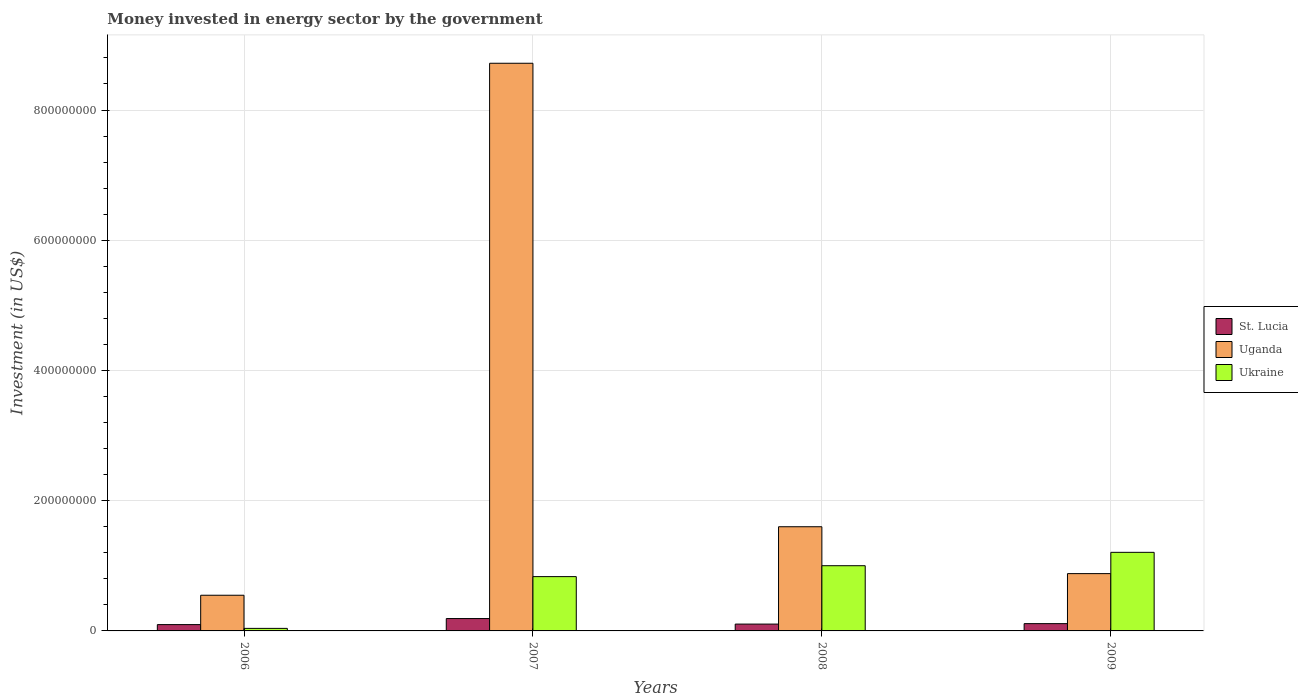How many groups of bars are there?
Your answer should be compact. 4. In how many cases, is the number of bars for a given year not equal to the number of legend labels?
Make the answer very short. 0. What is the money spent in energy sector in Ukraine in 2007?
Offer a terse response. 8.34e+07. Across all years, what is the maximum money spent in energy sector in Ukraine?
Ensure brevity in your answer.  1.21e+08. Across all years, what is the minimum money spent in energy sector in Uganda?
Provide a succinct answer. 5.48e+07. In which year was the money spent in energy sector in St. Lucia maximum?
Ensure brevity in your answer.  2007. What is the total money spent in energy sector in St. Lucia in the graph?
Offer a terse response. 5.04e+07. What is the difference between the money spent in energy sector in Uganda in 2006 and that in 2007?
Make the answer very short. -8.17e+08. What is the difference between the money spent in energy sector in St. Lucia in 2008 and the money spent in energy sector in Ukraine in 2006?
Your answer should be very brief. 6.60e+06. What is the average money spent in energy sector in Uganda per year?
Your answer should be compact. 2.94e+08. In the year 2008, what is the difference between the money spent in energy sector in Uganda and money spent in energy sector in St. Lucia?
Keep it short and to the point. 1.50e+08. In how many years, is the money spent in energy sector in St. Lucia greater than 800000000 US$?
Offer a very short reply. 0. What is the ratio of the money spent in energy sector in St. Lucia in 2006 to that in 2009?
Your response must be concise. 0.87. Is the difference between the money spent in energy sector in Uganda in 2008 and 2009 greater than the difference between the money spent in energy sector in St. Lucia in 2008 and 2009?
Keep it short and to the point. Yes. What is the difference between the highest and the second highest money spent in energy sector in Ukraine?
Offer a terse response. 2.06e+07. What is the difference between the highest and the lowest money spent in energy sector in Uganda?
Provide a succinct answer. 8.17e+08. In how many years, is the money spent in energy sector in Ukraine greater than the average money spent in energy sector in Ukraine taken over all years?
Ensure brevity in your answer.  3. Is the sum of the money spent in energy sector in St. Lucia in 2007 and 2009 greater than the maximum money spent in energy sector in Uganda across all years?
Your response must be concise. No. What does the 1st bar from the left in 2006 represents?
Offer a very short reply. St. Lucia. What does the 3rd bar from the right in 2006 represents?
Give a very brief answer. St. Lucia. Is it the case that in every year, the sum of the money spent in energy sector in St. Lucia and money spent in energy sector in Uganda is greater than the money spent in energy sector in Ukraine?
Provide a succinct answer. No. How many years are there in the graph?
Provide a succinct answer. 4. How many legend labels are there?
Keep it short and to the point. 3. How are the legend labels stacked?
Give a very brief answer. Vertical. What is the title of the graph?
Give a very brief answer. Money invested in energy sector by the government. Does "Tuvalu" appear as one of the legend labels in the graph?
Provide a succinct answer. No. What is the label or title of the X-axis?
Make the answer very short. Years. What is the label or title of the Y-axis?
Your answer should be compact. Investment (in US$). What is the Investment (in US$) of St. Lucia in 2006?
Make the answer very short. 9.70e+06. What is the Investment (in US$) in Uganda in 2006?
Provide a short and direct response. 5.48e+07. What is the Investment (in US$) in Ukraine in 2006?
Your answer should be very brief. 3.90e+06. What is the Investment (in US$) of St. Lucia in 2007?
Ensure brevity in your answer.  1.90e+07. What is the Investment (in US$) of Uganda in 2007?
Provide a short and direct response. 8.72e+08. What is the Investment (in US$) in Ukraine in 2007?
Your answer should be very brief. 8.34e+07. What is the Investment (in US$) of St. Lucia in 2008?
Ensure brevity in your answer.  1.05e+07. What is the Investment (in US$) of Uganda in 2008?
Your answer should be compact. 1.60e+08. What is the Investment (in US$) in Ukraine in 2008?
Your response must be concise. 1.00e+08. What is the Investment (in US$) in St. Lucia in 2009?
Your answer should be very brief. 1.12e+07. What is the Investment (in US$) of Uganda in 2009?
Give a very brief answer. 8.80e+07. What is the Investment (in US$) of Ukraine in 2009?
Offer a terse response. 1.21e+08. Across all years, what is the maximum Investment (in US$) in St. Lucia?
Provide a short and direct response. 1.90e+07. Across all years, what is the maximum Investment (in US$) of Uganda?
Offer a very short reply. 8.72e+08. Across all years, what is the maximum Investment (in US$) in Ukraine?
Offer a terse response. 1.21e+08. Across all years, what is the minimum Investment (in US$) in St. Lucia?
Make the answer very short. 9.70e+06. Across all years, what is the minimum Investment (in US$) of Uganda?
Make the answer very short. 5.48e+07. Across all years, what is the minimum Investment (in US$) in Ukraine?
Your answer should be very brief. 3.90e+06. What is the total Investment (in US$) of St. Lucia in the graph?
Provide a succinct answer. 5.04e+07. What is the total Investment (in US$) of Uganda in the graph?
Give a very brief answer. 1.17e+09. What is the total Investment (in US$) of Ukraine in the graph?
Ensure brevity in your answer.  3.08e+08. What is the difference between the Investment (in US$) of St. Lucia in 2006 and that in 2007?
Your response must be concise. -9.30e+06. What is the difference between the Investment (in US$) of Uganda in 2006 and that in 2007?
Offer a very short reply. -8.17e+08. What is the difference between the Investment (in US$) in Ukraine in 2006 and that in 2007?
Your answer should be compact. -7.95e+07. What is the difference between the Investment (in US$) of St. Lucia in 2006 and that in 2008?
Keep it short and to the point. -8.00e+05. What is the difference between the Investment (in US$) in Uganda in 2006 and that in 2008?
Provide a short and direct response. -1.05e+08. What is the difference between the Investment (in US$) of Ukraine in 2006 and that in 2008?
Your answer should be compact. -9.62e+07. What is the difference between the Investment (in US$) in St. Lucia in 2006 and that in 2009?
Keep it short and to the point. -1.50e+06. What is the difference between the Investment (in US$) in Uganda in 2006 and that in 2009?
Offer a very short reply. -3.32e+07. What is the difference between the Investment (in US$) of Ukraine in 2006 and that in 2009?
Give a very brief answer. -1.17e+08. What is the difference between the Investment (in US$) of St. Lucia in 2007 and that in 2008?
Offer a terse response. 8.50e+06. What is the difference between the Investment (in US$) in Uganda in 2007 and that in 2008?
Your answer should be very brief. 7.12e+08. What is the difference between the Investment (in US$) of Ukraine in 2007 and that in 2008?
Offer a very short reply. -1.67e+07. What is the difference between the Investment (in US$) of St. Lucia in 2007 and that in 2009?
Your answer should be very brief. 7.80e+06. What is the difference between the Investment (in US$) in Uganda in 2007 and that in 2009?
Your answer should be very brief. 7.84e+08. What is the difference between the Investment (in US$) of Ukraine in 2007 and that in 2009?
Your answer should be compact. -3.73e+07. What is the difference between the Investment (in US$) of St. Lucia in 2008 and that in 2009?
Your response must be concise. -7.00e+05. What is the difference between the Investment (in US$) of Uganda in 2008 and that in 2009?
Provide a short and direct response. 7.20e+07. What is the difference between the Investment (in US$) of Ukraine in 2008 and that in 2009?
Offer a very short reply. -2.06e+07. What is the difference between the Investment (in US$) of St. Lucia in 2006 and the Investment (in US$) of Uganda in 2007?
Offer a very short reply. -8.62e+08. What is the difference between the Investment (in US$) of St. Lucia in 2006 and the Investment (in US$) of Ukraine in 2007?
Keep it short and to the point. -7.37e+07. What is the difference between the Investment (in US$) in Uganda in 2006 and the Investment (in US$) in Ukraine in 2007?
Offer a very short reply. -2.86e+07. What is the difference between the Investment (in US$) in St. Lucia in 2006 and the Investment (in US$) in Uganda in 2008?
Provide a short and direct response. -1.50e+08. What is the difference between the Investment (in US$) in St. Lucia in 2006 and the Investment (in US$) in Ukraine in 2008?
Offer a terse response. -9.04e+07. What is the difference between the Investment (in US$) in Uganda in 2006 and the Investment (in US$) in Ukraine in 2008?
Make the answer very short. -4.53e+07. What is the difference between the Investment (in US$) in St. Lucia in 2006 and the Investment (in US$) in Uganda in 2009?
Your answer should be very brief. -7.83e+07. What is the difference between the Investment (in US$) in St. Lucia in 2006 and the Investment (in US$) in Ukraine in 2009?
Make the answer very short. -1.11e+08. What is the difference between the Investment (in US$) of Uganda in 2006 and the Investment (in US$) of Ukraine in 2009?
Your answer should be compact. -6.59e+07. What is the difference between the Investment (in US$) in St. Lucia in 2007 and the Investment (in US$) in Uganda in 2008?
Your response must be concise. -1.41e+08. What is the difference between the Investment (in US$) of St. Lucia in 2007 and the Investment (in US$) of Ukraine in 2008?
Give a very brief answer. -8.11e+07. What is the difference between the Investment (in US$) of Uganda in 2007 and the Investment (in US$) of Ukraine in 2008?
Provide a short and direct response. 7.72e+08. What is the difference between the Investment (in US$) in St. Lucia in 2007 and the Investment (in US$) in Uganda in 2009?
Provide a succinct answer. -6.90e+07. What is the difference between the Investment (in US$) in St. Lucia in 2007 and the Investment (in US$) in Ukraine in 2009?
Your answer should be very brief. -1.02e+08. What is the difference between the Investment (in US$) in Uganda in 2007 and the Investment (in US$) in Ukraine in 2009?
Keep it short and to the point. 7.51e+08. What is the difference between the Investment (in US$) of St. Lucia in 2008 and the Investment (in US$) of Uganda in 2009?
Give a very brief answer. -7.75e+07. What is the difference between the Investment (in US$) of St. Lucia in 2008 and the Investment (in US$) of Ukraine in 2009?
Your response must be concise. -1.10e+08. What is the difference between the Investment (in US$) of Uganda in 2008 and the Investment (in US$) of Ukraine in 2009?
Offer a terse response. 3.93e+07. What is the average Investment (in US$) of St. Lucia per year?
Offer a very short reply. 1.26e+07. What is the average Investment (in US$) in Uganda per year?
Give a very brief answer. 2.94e+08. What is the average Investment (in US$) of Ukraine per year?
Offer a terse response. 7.70e+07. In the year 2006, what is the difference between the Investment (in US$) in St. Lucia and Investment (in US$) in Uganda?
Provide a succinct answer. -4.51e+07. In the year 2006, what is the difference between the Investment (in US$) of St. Lucia and Investment (in US$) of Ukraine?
Ensure brevity in your answer.  5.80e+06. In the year 2006, what is the difference between the Investment (in US$) of Uganda and Investment (in US$) of Ukraine?
Your answer should be compact. 5.09e+07. In the year 2007, what is the difference between the Investment (in US$) in St. Lucia and Investment (in US$) in Uganda?
Give a very brief answer. -8.53e+08. In the year 2007, what is the difference between the Investment (in US$) in St. Lucia and Investment (in US$) in Ukraine?
Your answer should be very brief. -6.44e+07. In the year 2007, what is the difference between the Investment (in US$) in Uganda and Investment (in US$) in Ukraine?
Make the answer very short. 7.88e+08. In the year 2008, what is the difference between the Investment (in US$) of St. Lucia and Investment (in US$) of Uganda?
Keep it short and to the point. -1.50e+08. In the year 2008, what is the difference between the Investment (in US$) of St. Lucia and Investment (in US$) of Ukraine?
Provide a succinct answer. -8.96e+07. In the year 2008, what is the difference between the Investment (in US$) of Uganda and Investment (in US$) of Ukraine?
Ensure brevity in your answer.  5.99e+07. In the year 2009, what is the difference between the Investment (in US$) of St. Lucia and Investment (in US$) of Uganda?
Provide a succinct answer. -7.68e+07. In the year 2009, what is the difference between the Investment (in US$) in St. Lucia and Investment (in US$) in Ukraine?
Your answer should be very brief. -1.09e+08. In the year 2009, what is the difference between the Investment (in US$) in Uganda and Investment (in US$) in Ukraine?
Provide a succinct answer. -3.27e+07. What is the ratio of the Investment (in US$) in St. Lucia in 2006 to that in 2007?
Your answer should be compact. 0.51. What is the ratio of the Investment (in US$) of Uganda in 2006 to that in 2007?
Your answer should be compact. 0.06. What is the ratio of the Investment (in US$) in Ukraine in 2006 to that in 2007?
Offer a very short reply. 0.05. What is the ratio of the Investment (in US$) of St. Lucia in 2006 to that in 2008?
Offer a very short reply. 0.92. What is the ratio of the Investment (in US$) of Uganda in 2006 to that in 2008?
Your answer should be very brief. 0.34. What is the ratio of the Investment (in US$) of Ukraine in 2006 to that in 2008?
Your response must be concise. 0.04. What is the ratio of the Investment (in US$) of St. Lucia in 2006 to that in 2009?
Your answer should be very brief. 0.87. What is the ratio of the Investment (in US$) of Uganda in 2006 to that in 2009?
Provide a short and direct response. 0.62. What is the ratio of the Investment (in US$) in Ukraine in 2006 to that in 2009?
Provide a short and direct response. 0.03. What is the ratio of the Investment (in US$) of St. Lucia in 2007 to that in 2008?
Your response must be concise. 1.81. What is the ratio of the Investment (in US$) of Uganda in 2007 to that in 2008?
Your answer should be compact. 5.45. What is the ratio of the Investment (in US$) in Ukraine in 2007 to that in 2008?
Provide a succinct answer. 0.83. What is the ratio of the Investment (in US$) of St. Lucia in 2007 to that in 2009?
Your answer should be compact. 1.7. What is the ratio of the Investment (in US$) in Uganda in 2007 to that in 2009?
Your response must be concise. 9.91. What is the ratio of the Investment (in US$) of Ukraine in 2007 to that in 2009?
Ensure brevity in your answer.  0.69. What is the ratio of the Investment (in US$) of Uganda in 2008 to that in 2009?
Your answer should be compact. 1.82. What is the ratio of the Investment (in US$) in Ukraine in 2008 to that in 2009?
Provide a succinct answer. 0.83. What is the difference between the highest and the second highest Investment (in US$) of St. Lucia?
Provide a short and direct response. 7.80e+06. What is the difference between the highest and the second highest Investment (in US$) in Uganda?
Offer a very short reply. 7.12e+08. What is the difference between the highest and the second highest Investment (in US$) in Ukraine?
Offer a terse response. 2.06e+07. What is the difference between the highest and the lowest Investment (in US$) of St. Lucia?
Your answer should be compact. 9.30e+06. What is the difference between the highest and the lowest Investment (in US$) of Uganda?
Provide a short and direct response. 8.17e+08. What is the difference between the highest and the lowest Investment (in US$) in Ukraine?
Your answer should be compact. 1.17e+08. 